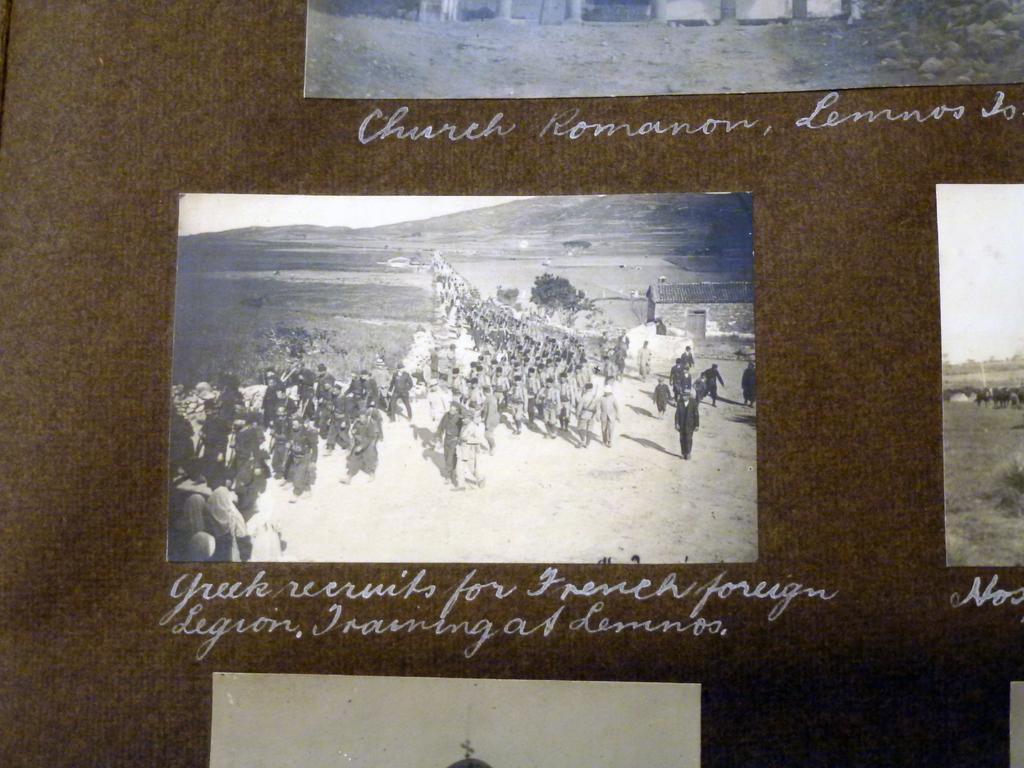Can you describe this image briefly? In this image I can see few papers attached to some object and the object is in brown color. I can also see something written with white color. 